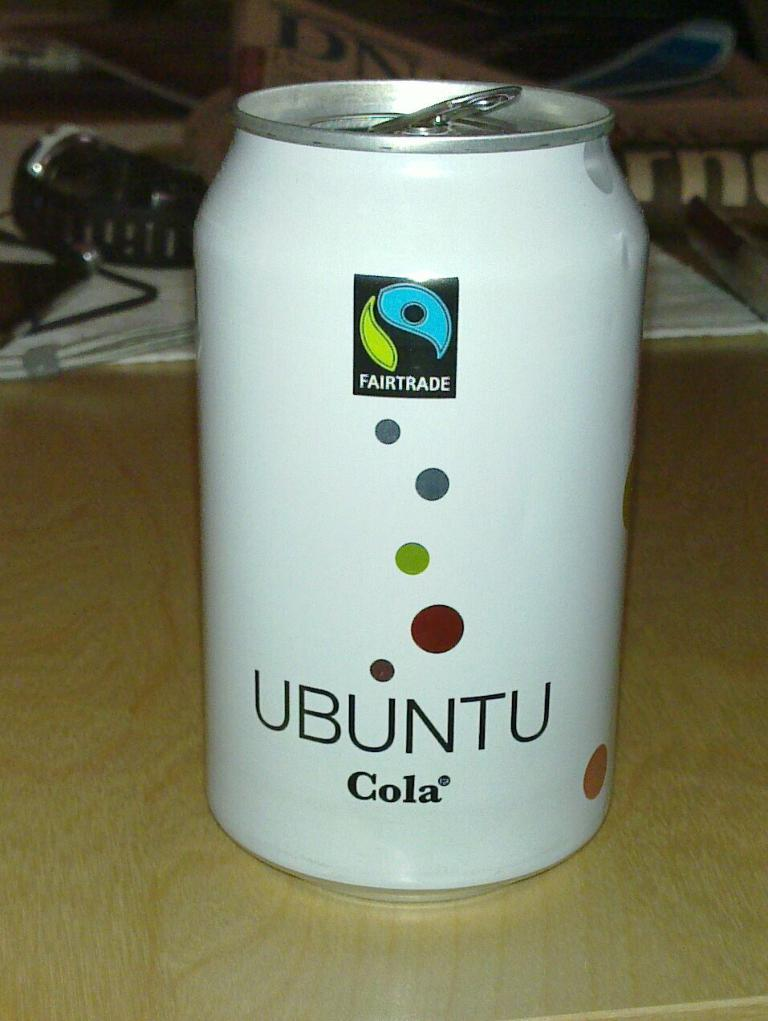<image>
Render a clear and concise summary of the photo. A white soda can says Ubuntu Cola and a wrist watch is behind it on the table. 